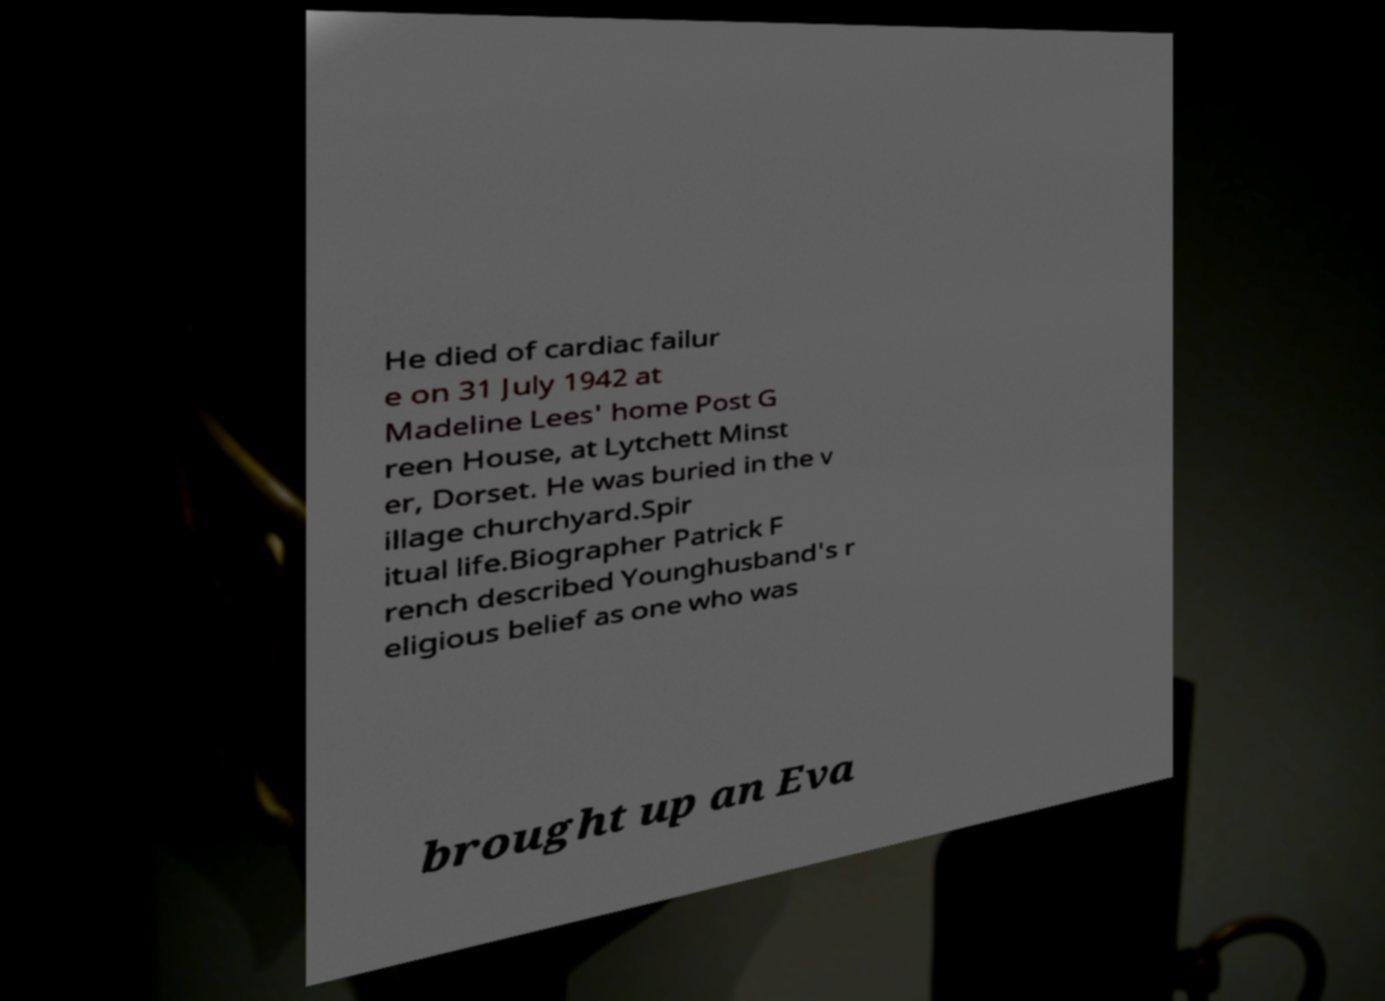Can you read and provide the text displayed in the image?This photo seems to have some interesting text. Can you extract and type it out for me? He died of cardiac failur e on 31 July 1942 at Madeline Lees' home Post G reen House, at Lytchett Minst er, Dorset. He was buried in the v illage churchyard.Spir itual life.Biographer Patrick F rench described Younghusband's r eligious belief as one who was brought up an Eva 